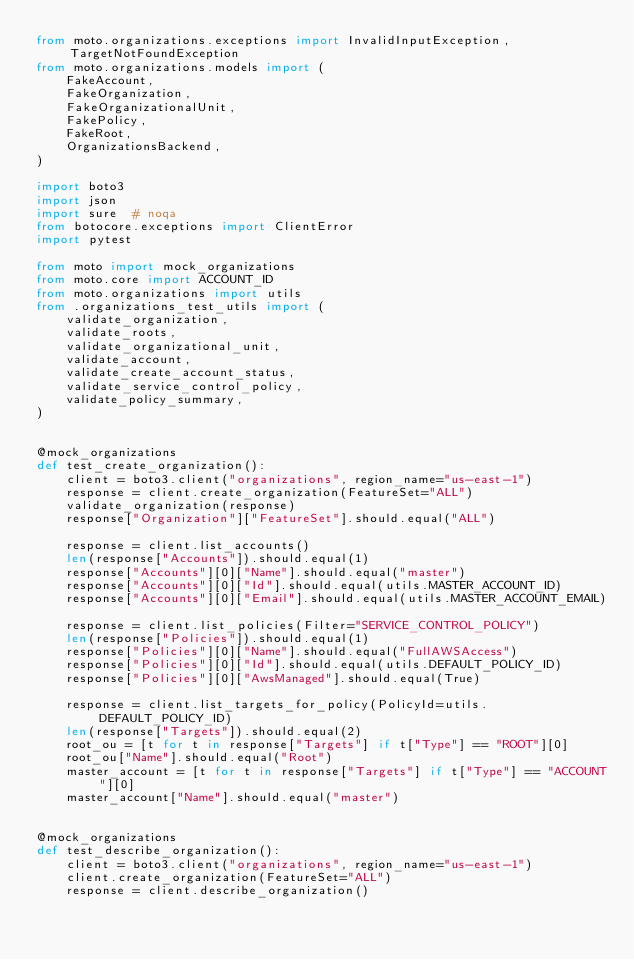Convert code to text. <code><loc_0><loc_0><loc_500><loc_500><_Python_>from moto.organizations.exceptions import InvalidInputException, TargetNotFoundException
from moto.organizations.models import (
    FakeAccount,
    FakeOrganization,
    FakeOrganizationalUnit,
    FakePolicy,
    FakeRoot,
    OrganizationsBackend,
)

import boto3
import json
import sure  # noqa
from botocore.exceptions import ClientError
import pytest

from moto import mock_organizations
from moto.core import ACCOUNT_ID
from moto.organizations import utils
from .organizations_test_utils import (
    validate_organization,
    validate_roots,
    validate_organizational_unit,
    validate_account,
    validate_create_account_status,
    validate_service_control_policy,
    validate_policy_summary,
)


@mock_organizations
def test_create_organization():
    client = boto3.client("organizations", region_name="us-east-1")
    response = client.create_organization(FeatureSet="ALL")
    validate_organization(response)
    response["Organization"]["FeatureSet"].should.equal("ALL")

    response = client.list_accounts()
    len(response["Accounts"]).should.equal(1)
    response["Accounts"][0]["Name"].should.equal("master")
    response["Accounts"][0]["Id"].should.equal(utils.MASTER_ACCOUNT_ID)
    response["Accounts"][0]["Email"].should.equal(utils.MASTER_ACCOUNT_EMAIL)

    response = client.list_policies(Filter="SERVICE_CONTROL_POLICY")
    len(response["Policies"]).should.equal(1)
    response["Policies"][0]["Name"].should.equal("FullAWSAccess")
    response["Policies"][0]["Id"].should.equal(utils.DEFAULT_POLICY_ID)
    response["Policies"][0]["AwsManaged"].should.equal(True)

    response = client.list_targets_for_policy(PolicyId=utils.DEFAULT_POLICY_ID)
    len(response["Targets"]).should.equal(2)
    root_ou = [t for t in response["Targets"] if t["Type"] == "ROOT"][0]
    root_ou["Name"].should.equal("Root")
    master_account = [t for t in response["Targets"] if t["Type"] == "ACCOUNT"][0]
    master_account["Name"].should.equal("master")


@mock_organizations
def test_describe_organization():
    client = boto3.client("organizations", region_name="us-east-1")
    client.create_organization(FeatureSet="ALL")
    response = client.describe_organization()</code> 